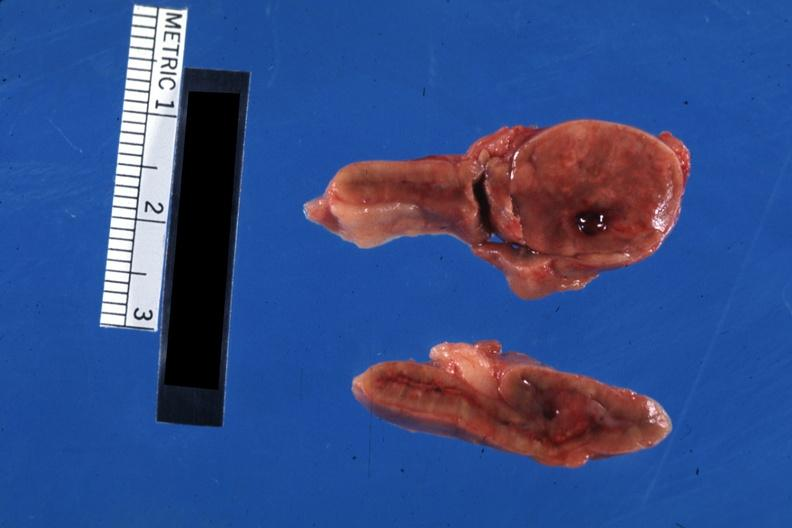s aldehyde fuscin present?
Answer the question using a single word or phrase. No 